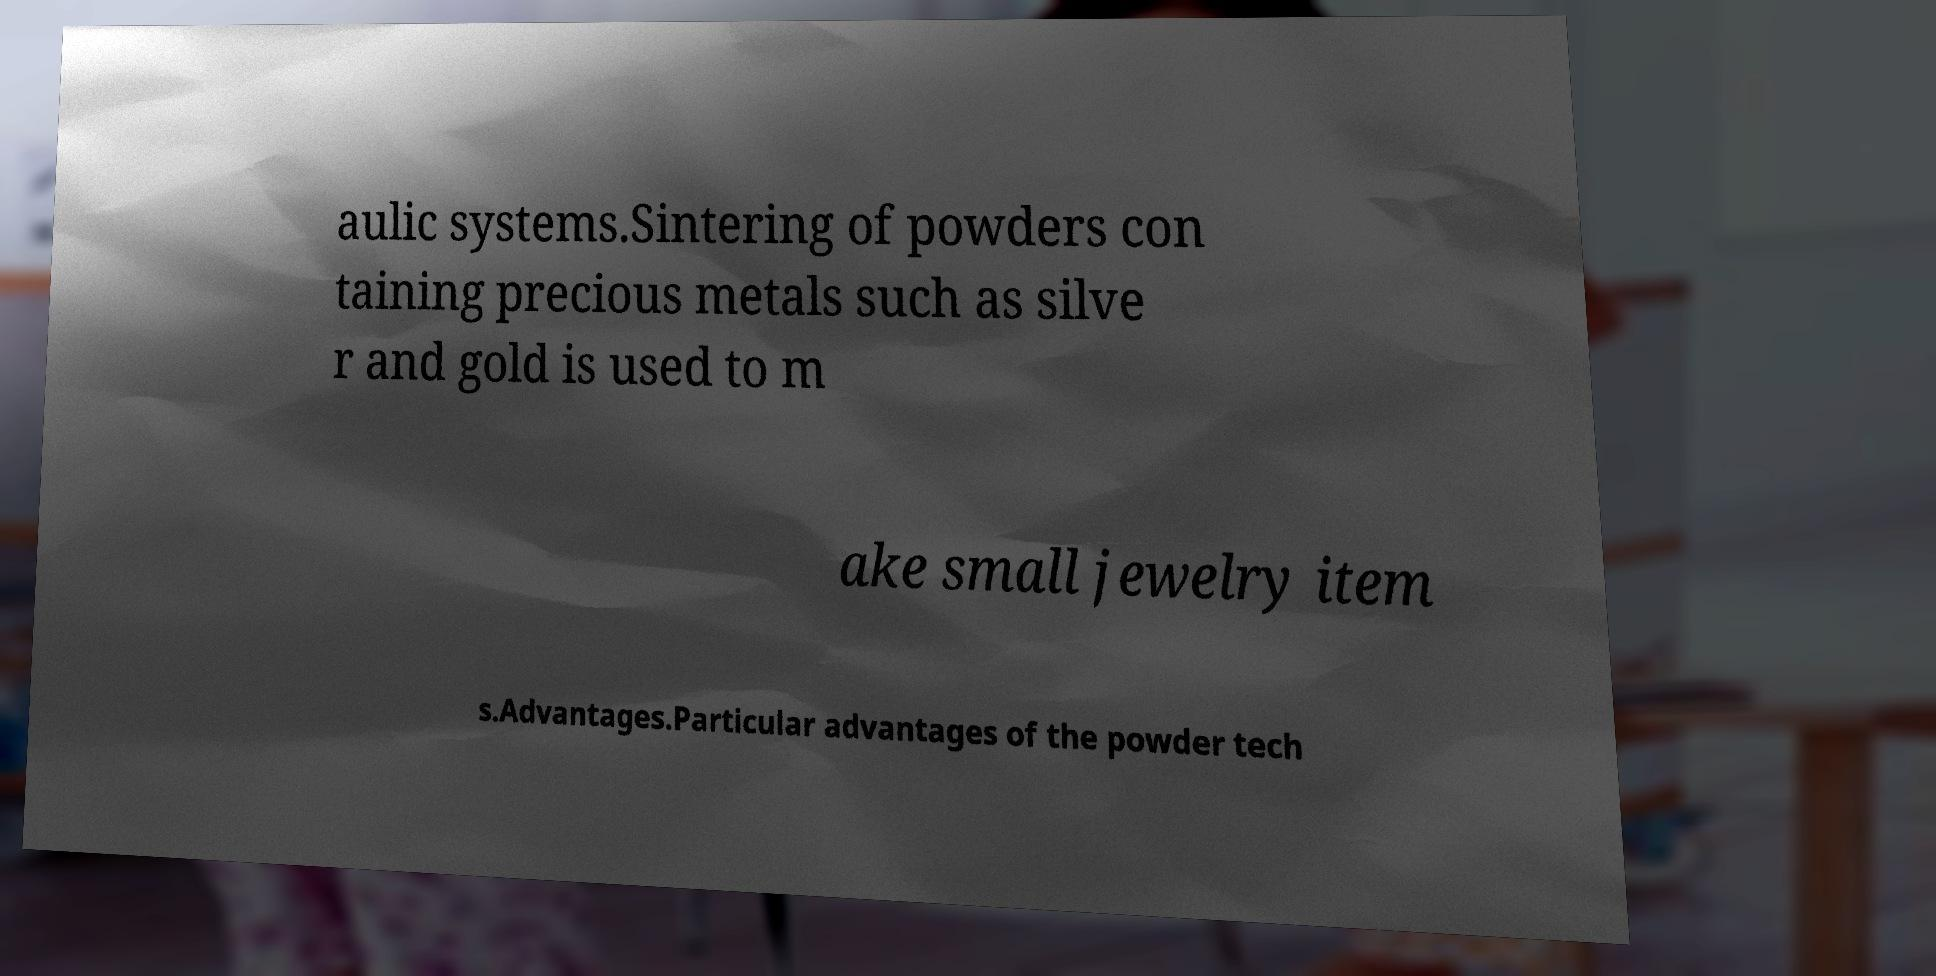Can you read and provide the text displayed in the image?This photo seems to have some interesting text. Can you extract and type it out for me? aulic systems.Sintering of powders con taining precious metals such as silve r and gold is used to m ake small jewelry item s.Advantages.Particular advantages of the powder tech 